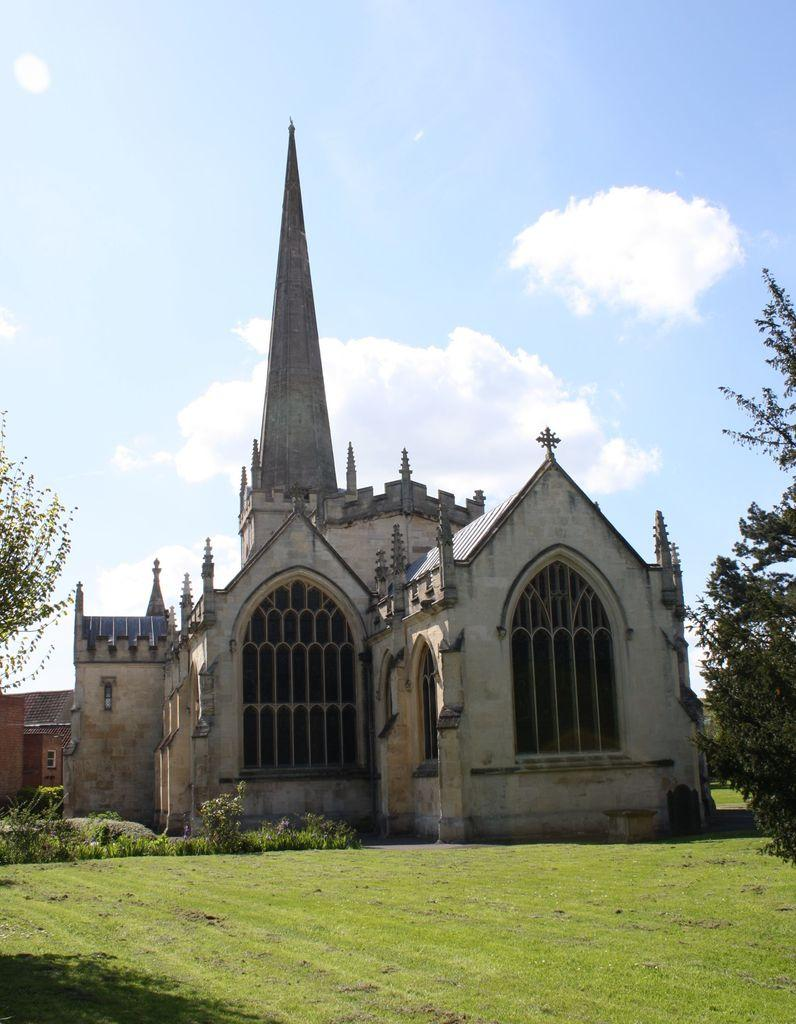What type of vegetation can be seen in the image? There is grass, plants, and trees in the image. What type of structures are present in the image? There is a building and a house in the image. What is visible in the background of the image? The sky is visible in the background of the image. What can be seen in the sky? There are clouds in the sky. What brand of toothpaste is being advertised on the house in the image? There is no toothpaste or advertisement present on the house in the image. What is your opinion on the architectural design of the building in the image? The provided facts do not include any information about the architectural design of the building, so it is not possible to provide an opinion. 